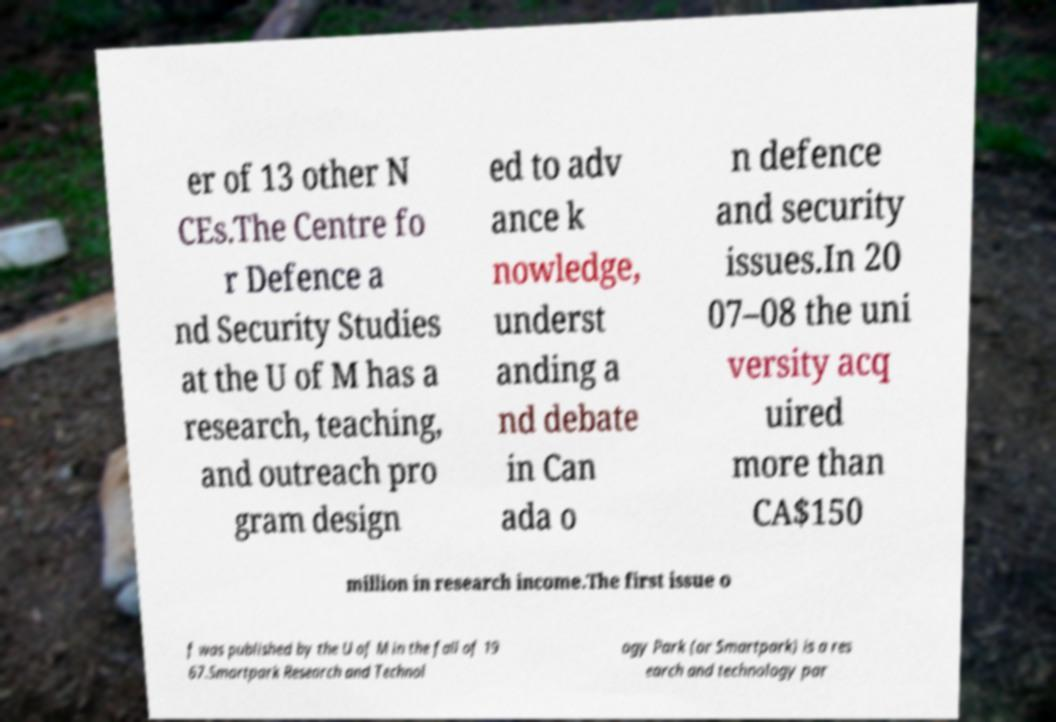Please read and relay the text visible in this image. What does it say? er of 13 other N CEs.The Centre fo r Defence a nd Security Studies at the U of M has a research, teaching, and outreach pro gram design ed to adv ance k nowledge, underst anding a nd debate in Can ada o n defence and security issues.In 20 07–08 the uni versity acq uired more than CA$150 million in research income.The first issue o f was published by the U of M in the fall of 19 67.Smartpark Research and Technol ogy Park (or Smartpark) is a res earch and technology par 